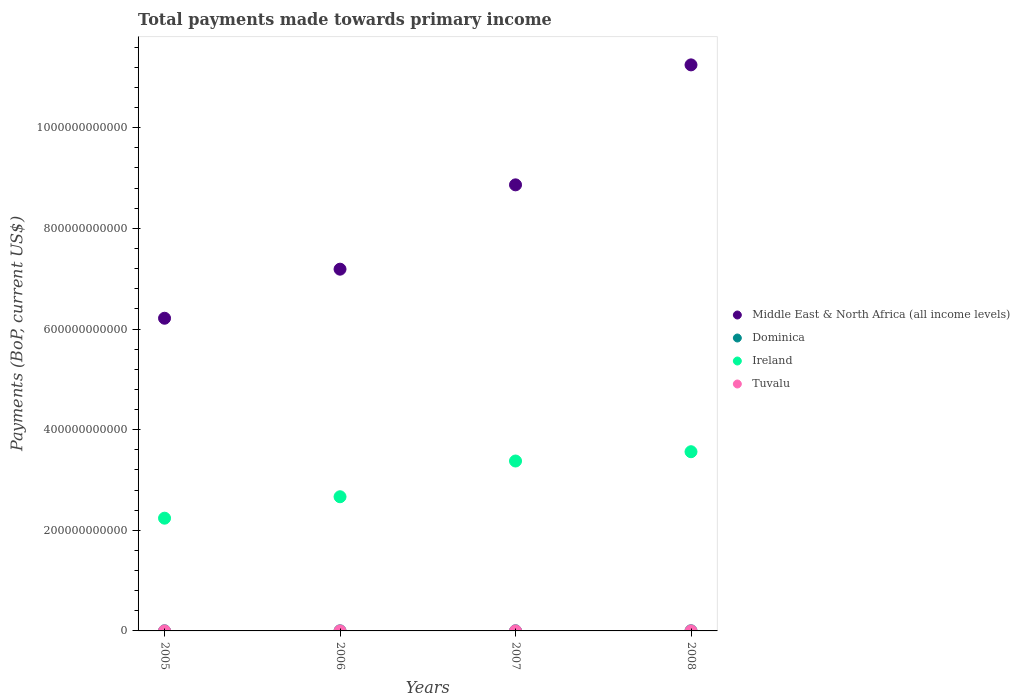How many different coloured dotlines are there?
Offer a terse response. 4. What is the total payments made towards primary income in Ireland in 2005?
Your response must be concise. 2.24e+11. Across all years, what is the maximum total payments made towards primary income in Ireland?
Offer a very short reply. 3.56e+11. Across all years, what is the minimum total payments made towards primary income in Dominica?
Your response must be concise. 2.20e+08. In which year was the total payments made towards primary income in Tuvalu minimum?
Make the answer very short. 2005. What is the total total payments made towards primary income in Middle East & North Africa (all income levels) in the graph?
Offer a terse response. 3.35e+12. What is the difference between the total payments made towards primary income in Middle East & North Africa (all income levels) in 2006 and that in 2007?
Give a very brief answer. -1.68e+11. What is the difference between the total payments made towards primary income in Tuvalu in 2006 and the total payments made towards primary income in Middle East & North Africa (all income levels) in 2008?
Make the answer very short. -1.12e+12. What is the average total payments made towards primary income in Tuvalu per year?
Provide a succinct answer. 2.89e+07. In the year 2007, what is the difference between the total payments made towards primary income in Tuvalu and total payments made towards primary income in Middle East & North Africa (all income levels)?
Offer a very short reply. -8.86e+11. In how many years, is the total payments made towards primary income in Dominica greater than 640000000000 US$?
Your response must be concise. 0. What is the ratio of the total payments made towards primary income in Tuvalu in 2006 to that in 2007?
Offer a very short reply. 0.68. Is the total payments made towards primary income in Ireland in 2006 less than that in 2008?
Provide a succinct answer. Yes. What is the difference between the highest and the second highest total payments made towards primary income in Tuvalu?
Your response must be concise. 7.85e+06. What is the difference between the highest and the lowest total payments made towards primary income in Tuvalu?
Make the answer very short. 1.94e+07. Is the sum of the total payments made towards primary income in Tuvalu in 2005 and 2007 greater than the maximum total payments made towards primary income in Dominica across all years?
Offer a terse response. No. Is it the case that in every year, the sum of the total payments made towards primary income in Dominica and total payments made towards primary income in Tuvalu  is greater than the sum of total payments made towards primary income in Ireland and total payments made towards primary income in Middle East & North Africa (all income levels)?
Provide a succinct answer. No. Is it the case that in every year, the sum of the total payments made towards primary income in Tuvalu and total payments made towards primary income in Middle East & North Africa (all income levels)  is greater than the total payments made towards primary income in Ireland?
Offer a terse response. Yes. Does the total payments made towards primary income in Ireland monotonically increase over the years?
Provide a succinct answer. Yes. How many dotlines are there?
Offer a very short reply. 4. What is the difference between two consecutive major ticks on the Y-axis?
Offer a very short reply. 2.00e+11. Does the graph contain grids?
Ensure brevity in your answer.  No. Where does the legend appear in the graph?
Offer a very short reply. Center right. How many legend labels are there?
Provide a short and direct response. 4. What is the title of the graph?
Provide a succinct answer. Total payments made towards primary income. What is the label or title of the X-axis?
Your response must be concise. Years. What is the label or title of the Y-axis?
Give a very brief answer. Payments (BoP, current US$). What is the Payments (BoP, current US$) in Middle East & North Africa (all income levels) in 2005?
Your answer should be compact. 6.21e+11. What is the Payments (BoP, current US$) of Dominica in 2005?
Make the answer very short. 2.31e+08. What is the Payments (BoP, current US$) of Ireland in 2005?
Ensure brevity in your answer.  2.24e+11. What is the Payments (BoP, current US$) of Tuvalu in 2005?
Give a very brief answer. 2.09e+07. What is the Payments (BoP, current US$) in Middle East & North Africa (all income levels) in 2006?
Provide a succinct answer. 7.19e+11. What is the Payments (BoP, current US$) in Dominica in 2006?
Your answer should be very brief. 2.20e+08. What is the Payments (BoP, current US$) in Ireland in 2006?
Give a very brief answer. 2.67e+11. What is the Payments (BoP, current US$) of Tuvalu in 2006?
Ensure brevity in your answer.  2.22e+07. What is the Payments (BoP, current US$) of Middle East & North Africa (all income levels) in 2007?
Your response must be concise. 8.86e+11. What is the Payments (BoP, current US$) of Dominica in 2007?
Give a very brief answer. 2.64e+08. What is the Payments (BoP, current US$) in Ireland in 2007?
Your answer should be compact. 3.38e+11. What is the Payments (BoP, current US$) in Tuvalu in 2007?
Offer a terse response. 3.24e+07. What is the Payments (BoP, current US$) in Middle East & North Africa (all income levels) in 2008?
Give a very brief answer. 1.12e+12. What is the Payments (BoP, current US$) in Dominica in 2008?
Give a very brief answer. 3.14e+08. What is the Payments (BoP, current US$) in Ireland in 2008?
Provide a succinct answer. 3.56e+11. What is the Payments (BoP, current US$) in Tuvalu in 2008?
Ensure brevity in your answer.  4.03e+07. Across all years, what is the maximum Payments (BoP, current US$) in Middle East & North Africa (all income levels)?
Your answer should be compact. 1.12e+12. Across all years, what is the maximum Payments (BoP, current US$) of Dominica?
Provide a short and direct response. 3.14e+08. Across all years, what is the maximum Payments (BoP, current US$) in Ireland?
Keep it short and to the point. 3.56e+11. Across all years, what is the maximum Payments (BoP, current US$) in Tuvalu?
Make the answer very short. 4.03e+07. Across all years, what is the minimum Payments (BoP, current US$) in Middle East & North Africa (all income levels)?
Your answer should be compact. 6.21e+11. Across all years, what is the minimum Payments (BoP, current US$) of Dominica?
Your answer should be compact. 2.20e+08. Across all years, what is the minimum Payments (BoP, current US$) in Ireland?
Your answer should be very brief. 2.24e+11. Across all years, what is the minimum Payments (BoP, current US$) of Tuvalu?
Your response must be concise. 2.09e+07. What is the total Payments (BoP, current US$) of Middle East & North Africa (all income levels) in the graph?
Ensure brevity in your answer.  3.35e+12. What is the total Payments (BoP, current US$) in Dominica in the graph?
Your answer should be very brief. 1.03e+09. What is the total Payments (BoP, current US$) in Ireland in the graph?
Your response must be concise. 1.18e+12. What is the total Payments (BoP, current US$) of Tuvalu in the graph?
Give a very brief answer. 1.16e+08. What is the difference between the Payments (BoP, current US$) of Middle East & North Africa (all income levels) in 2005 and that in 2006?
Your answer should be compact. -9.75e+1. What is the difference between the Payments (BoP, current US$) in Dominica in 2005 and that in 2006?
Ensure brevity in your answer.  1.10e+07. What is the difference between the Payments (BoP, current US$) in Ireland in 2005 and that in 2006?
Offer a very short reply. -4.26e+1. What is the difference between the Payments (BoP, current US$) of Tuvalu in 2005 and that in 2006?
Ensure brevity in your answer.  -1.31e+06. What is the difference between the Payments (BoP, current US$) of Middle East & North Africa (all income levels) in 2005 and that in 2007?
Provide a succinct answer. -2.65e+11. What is the difference between the Payments (BoP, current US$) of Dominica in 2005 and that in 2007?
Offer a very short reply. -3.35e+07. What is the difference between the Payments (BoP, current US$) in Ireland in 2005 and that in 2007?
Your answer should be very brief. -1.14e+11. What is the difference between the Payments (BoP, current US$) of Tuvalu in 2005 and that in 2007?
Keep it short and to the point. -1.15e+07. What is the difference between the Payments (BoP, current US$) of Middle East & North Africa (all income levels) in 2005 and that in 2008?
Offer a terse response. -5.04e+11. What is the difference between the Payments (BoP, current US$) of Dominica in 2005 and that in 2008?
Offer a very short reply. -8.30e+07. What is the difference between the Payments (BoP, current US$) in Ireland in 2005 and that in 2008?
Your response must be concise. -1.32e+11. What is the difference between the Payments (BoP, current US$) of Tuvalu in 2005 and that in 2008?
Offer a very short reply. -1.94e+07. What is the difference between the Payments (BoP, current US$) in Middle East & North Africa (all income levels) in 2006 and that in 2007?
Make the answer very short. -1.68e+11. What is the difference between the Payments (BoP, current US$) of Dominica in 2006 and that in 2007?
Give a very brief answer. -4.45e+07. What is the difference between the Payments (BoP, current US$) in Ireland in 2006 and that in 2007?
Provide a succinct answer. -7.10e+1. What is the difference between the Payments (BoP, current US$) of Tuvalu in 2006 and that in 2007?
Your response must be concise. -1.02e+07. What is the difference between the Payments (BoP, current US$) in Middle East & North Africa (all income levels) in 2006 and that in 2008?
Keep it short and to the point. -4.06e+11. What is the difference between the Payments (BoP, current US$) in Dominica in 2006 and that in 2008?
Keep it short and to the point. -9.40e+07. What is the difference between the Payments (BoP, current US$) of Ireland in 2006 and that in 2008?
Make the answer very short. -8.95e+1. What is the difference between the Payments (BoP, current US$) in Tuvalu in 2006 and that in 2008?
Make the answer very short. -1.81e+07. What is the difference between the Payments (BoP, current US$) of Middle East & North Africa (all income levels) in 2007 and that in 2008?
Provide a succinct answer. -2.38e+11. What is the difference between the Payments (BoP, current US$) of Dominica in 2007 and that in 2008?
Ensure brevity in your answer.  -4.96e+07. What is the difference between the Payments (BoP, current US$) of Ireland in 2007 and that in 2008?
Give a very brief answer. -1.85e+1. What is the difference between the Payments (BoP, current US$) in Tuvalu in 2007 and that in 2008?
Give a very brief answer. -7.85e+06. What is the difference between the Payments (BoP, current US$) in Middle East & North Africa (all income levels) in 2005 and the Payments (BoP, current US$) in Dominica in 2006?
Your answer should be compact. 6.21e+11. What is the difference between the Payments (BoP, current US$) in Middle East & North Africa (all income levels) in 2005 and the Payments (BoP, current US$) in Ireland in 2006?
Offer a very short reply. 3.55e+11. What is the difference between the Payments (BoP, current US$) in Middle East & North Africa (all income levels) in 2005 and the Payments (BoP, current US$) in Tuvalu in 2006?
Give a very brief answer. 6.21e+11. What is the difference between the Payments (BoP, current US$) in Dominica in 2005 and the Payments (BoP, current US$) in Ireland in 2006?
Your response must be concise. -2.66e+11. What is the difference between the Payments (BoP, current US$) of Dominica in 2005 and the Payments (BoP, current US$) of Tuvalu in 2006?
Offer a very short reply. 2.09e+08. What is the difference between the Payments (BoP, current US$) in Ireland in 2005 and the Payments (BoP, current US$) in Tuvalu in 2006?
Ensure brevity in your answer.  2.24e+11. What is the difference between the Payments (BoP, current US$) in Middle East & North Africa (all income levels) in 2005 and the Payments (BoP, current US$) in Dominica in 2007?
Ensure brevity in your answer.  6.21e+11. What is the difference between the Payments (BoP, current US$) of Middle East & North Africa (all income levels) in 2005 and the Payments (BoP, current US$) of Ireland in 2007?
Offer a terse response. 2.84e+11. What is the difference between the Payments (BoP, current US$) of Middle East & North Africa (all income levels) in 2005 and the Payments (BoP, current US$) of Tuvalu in 2007?
Your response must be concise. 6.21e+11. What is the difference between the Payments (BoP, current US$) in Dominica in 2005 and the Payments (BoP, current US$) in Ireland in 2007?
Provide a short and direct response. -3.37e+11. What is the difference between the Payments (BoP, current US$) of Dominica in 2005 and the Payments (BoP, current US$) of Tuvalu in 2007?
Make the answer very short. 1.99e+08. What is the difference between the Payments (BoP, current US$) of Ireland in 2005 and the Payments (BoP, current US$) of Tuvalu in 2007?
Offer a very short reply. 2.24e+11. What is the difference between the Payments (BoP, current US$) in Middle East & North Africa (all income levels) in 2005 and the Payments (BoP, current US$) in Dominica in 2008?
Your response must be concise. 6.21e+11. What is the difference between the Payments (BoP, current US$) of Middle East & North Africa (all income levels) in 2005 and the Payments (BoP, current US$) of Ireland in 2008?
Offer a very short reply. 2.65e+11. What is the difference between the Payments (BoP, current US$) of Middle East & North Africa (all income levels) in 2005 and the Payments (BoP, current US$) of Tuvalu in 2008?
Your answer should be compact. 6.21e+11. What is the difference between the Payments (BoP, current US$) of Dominica in 2005 and the Payments (BoP, current US$) of Ireland in 2008?
Your response must be concise. -3.56e+11. What is the difference between the Payments (BoP, current US$) of Dominica in 2005 and the Payments (BoP, current US$) of Tuvalu in 2008?
Provide a short and direct response. 1.91e+08. What is the difference between the Payments (BoP, current US$) in Ireland in 2005 and the Payments (BoP, current US$) in Tuvalu in 2008?
Ensure brevity in your answer.  2.24e+11. What is the difference between the Payments (BoP, current US$) in Middle East & North Africa (all income levels) in 2006 and the Payments (BoP, current US$) in Dominica in 2007?
Your response must be concise. 7.19e+11. What is the difference between the Payments (BoP, current US$) of Middle East & North Africa (all income levels) in 2006 and the Payments (BoP, current US$) of Ireland in 2007?
Provide a short and direct response. 3.81e+11. What is the difference between the Payments (BoP, current US$) in Middle East & North Africa (all income levels) in 2006 and the Payments (BoP, current US$) in Tuvalu in 2007?
Give a very brief answer. 7.19e+11. What is the difference between the Payments (BoP, current US$) of Dominica in 2006 and the Payments (BoP, current US$) of Ireland in 2007?
Your answer should be compact. -3.37e+11. What is the difference between the Payments (BoP, current US$) of Dominica in 2006 and the Payments (BoP, current US$) of Tuvalu in 2007?
Ensure brevity in your answer.  1.88e+08. What is the difference between the Payments (BoP, current US$) in Ireland in 2006 and the Payments (BoP, current US$) in Tuvalu in 2007?
Keep it short and to the point. 2.67e+11. What is the difference between the Payments (BoP, current US$) in Middle East & North Africa (all income levels) in 2006 and the Payments (BoP, current US$) in Dominica in 2008?
Your answer should be very brief. 7.19e+11. What is the difference between the Payments (BoP, current US$) in Middle East & North Africa (all income levels) in 2006 and the Payments (BoP, current US$) in Ireland in 2008?
Your answer should be compact. 3.63e+11. What is the difference between the Payments (BoP, current US$) in Middle East & North Africa (all income levels) in 2006 and the Payments (BoP, current US$) in Tuvalu in 2008?
Your answer should be very brief. 7.19e+11. What is the difference between the Payments (BoP, current US$) in Dominica in 2006 and the Payments (BoP, current US$) in Ireland in 2008?
Your response must be concise. -3.56e+11. What is the difference between the Payments (BoP, current US$) in Dominica in 2006 and the Payments (BoP, current US$) in Tuvalu in 2008?
Give a very brief answer. 1.80e+08. What is the difference between the Payments (BoP, current US$) in Ireland in 2006 and the Payments (BoP, current US$) in Tuvalu in 2008?
Your answer should be very brief. 2.67e+11. What is the difference between the Payments (BoP, current US$) of Middle East & North Africa (all income levels) in 2007 and the Payments (BoP, current US$) of Dominica in 2008?
Your answer should be very brief. 8.86e+11. What is the difference between the Payments (BoP, current US$) of Middle East & North Africa (all income levels) in 2007 and the Payments (BoP, current US$) of Ireland in 2008?
Provide a short and direct response. 5.30e+11. What is the difference between the Payments (BoP, current US$) in Middle East & North Africa (all income levels) in 2007 and the Payments (BoP, current US$) in Tuvalu in 2008?
Your answer should be compact. 8.86e+11. What is the difference between the Payments (BoP, current US$) of Dominica in 2007 and the Payments (BoP, current US$) of Ireland in 2008?
Provide a succinct answer. -3.56e+11. What is the difference between the Payments (BoP, current US$) of Dominica in 2007 and the Payments (BoP, current US$) of Tuvalu in 2008?
Make the answer very short. 2.24e+08. What is the difference between the Payments (BoP, current US$) of Ireland in 2007 and the Payments (BoP, current US$) of Tuvalu in 2008?
Provide a succinct answer. 3.38e+11. What is the average Payments (BoP, current US$) of Middle East & North Africa (all income levels) per year?
Ensure brevity in your answer.  8.38e+11. What is the average Payments (BoP, current US$) in Dominica per year?
Provide a succinct answer. 2.57e+08. What is the average Payments (BoP, current US$) of Ireland per year?
Ensure brevity in your answer.  2.96e+11. What is the average Payments (BoP, current US$) of Tuvalu per year?
Provide a succinct answer. 2.89e+07. In the year 2005, what is the difference between the Payments (BoP, current US$) in Middle East & North Africa (all income levels) and Payments (BoP, current US$) in Dominica?
Your answer should be compact. 6.21e+11. In the year 2005, what is the difference between the Payments (BoP, current US$) in Middle East & North Africa (all income levels) and Payments (BoP, current US$) in Ireland?
Make the answer very short. 3.97e+11. In the year 2005, what is the difference between the Payments (BoP, current US$) in Middle East & North Africa (all income levels) and Payments (BoP, current US$) in Tuvalu?
Give a very brief answer. 6.21e+11. In the year 2005, what is the difference between the Payments (BoP, current US$) in Dominica and Payments (BoP, current US$) in Ireland?
Your answer should be compact. -2.24e+11. In the year 2005, what is the difference between the Payments (BoP, current US$) in Dominica and Payments (BoP, current US$) in Tuvalu?
Give a very brief answer. 2.10e+08. In the year 2005, what is the difference between the Payments (BoP, current US$) in Ireland and Payments (BoP, current US$) in Tuvalu?
Your answer should be very brief. 2.24e+11. In the year 2006, what is the difference between the Payments (BoP, current US$) in Middle East & North Africa (all income levels) and Payments (BoP, current US$) in Dominica?
Ensure brevity in your answer.  7.19e+11. In the year 2006, what is the difference between the Payments (BoP, current US$) in Middle East & North Africa (all income levels) and Payments (BoP, current US$) in Ireland?
Provide a succinct answer. 4.52e+11. In the year 2006, what is the difference between the Payments (BoP, current US$) of Middle East & North Africa (all income levels) and Payments (BoP, current US$) of Tuvalu?
Your response must be concise. 7.19e+11. In the year 2006, what is the difference between the Payments (BoP, current US$) of Dominica and Payments (BoP, current US$) of Ireland?
Give a very brief answer. -2.66e+11. In the year 2006, what is the difference between the Payments (BoP, current US$) in Dominica and Payments (BoP, current US$) in Tuvalu?
Your response must be concise. 1.98e+08. In the year 2006, what is the difference between the Payments (BoP, current US$) of Ireland and Payments (BoP, current US$) of Tuvalu?
Offer a terse response. 2.67e+11. In the year 2007, what is the difference between the Payments (BoP, current US$) in Middle East & North Africa (all income levels) and Payments (BoP, current US$) in Dominica?
Offer a very short reply. 8.86e+11. In the year 2007, what is the difference between the Payments (BoP, current US$) in Middle East & North Africa (all income levels) and Payments (BoP, current US$) in Ireland?
Make the answer very short. 5.49e+11. In the year 2007, what is the difference between the Payments (BoP, current US$) of Middle East & North Africa (all income levels) and Payments (BoP, current US$) of Tuvalu?
Offer a terse response. 8.86e+11. In the year 2007, what is the difference between the Payments (BoP, current US$) in Dominica and Payments (BoP, current US$) in Ireland?
Offer a very short reply. -3.37e+11. In the year 2007, what is the difference between the Payments (BoP, current US$) of Dominica and Payments (BoP, current US$) of Tuvalu?
Make the answer very short. 2.32e+08. In the year 2007, what is the difference between the Payments (BoP, current US$) in Ireland and Payments (BoP, current US$) in Tuvalu?
Provide a succinct answer. 3.38e+11. In the year 2008, what is the difference between the Payments (BoP, current US$) of Middle East & North Africa (all income levels) and Payments (BoP, current US$) of Dominica?
Offer a terse response. 1.12e+12. In the year 2008, what is the difference between the Payments (BoP, current US$) of Middle East & North Africa (all income levels) and Payments (BoP, current US$) of Ireland?
Offer a terse response. 7.69e+11. In the year 2008, what is the difference between the Payments (BoP, current US$) in Middle East & North Africa (all income levels) and Payments (BoP, current US$) in Tuvalu?
Offer a terse response. 1.12e+12. In the year 2008, what is the difference between the Payments (BoP, current US$) in Dominica and Payments (BoP, current US$) in Ireland?
Provide a succinct answer. -3.56e+11. In the year 2008, what is the difference between the Payments (BoP, current US$) in Dominica and Payments (BoP, current US$) in Tuvalu?
Keep it short and to the point. 2.74e+08. In the year 2008, what is the difference between the Payments (BoP, current US$) of Ireland and Payments (BoP, current US$) of Tuvalu?
Provide a succinct answer. 3.56e+11. What is the ratio of the Payments (BoP, current US$) in Middle East & North Africa (all income levels) in 2005 to that in 2006?
Ensure brevity in your answer.  0.86. What is the ratio of the Payments (BoP, current US$) of Dominica in 2005 to that in 2006?
Make the answer very short. 1.05. What is the ratio of the Payments (BoP, current US$) in Ireland in 2005 to that in 2006?
Your answer should be very brief. 0.84. What is the ratio of the Payments (BoP, current US$) in Tuvalu in 2005 to that in 2006?
Provide a short and direct response. 0.94. What is the ratio of the Payments (BoP, current US$) in Middle East & North Africa (all income levels) in 2005 to that in 2007?
Your answer should be very brief. 0.7. What is the ratio of the Payments (BoP, current US$) in Dominica in 2005 to that in 2007?
Keep it short and to the point. 0.87. What is the ratio of the Payments (BoP, current US$) of Ireland in 2005 to that in 2007?
Give a very brief answer. 0.66. What is the ratio of the Payments (BoP, current US$) in Tuvalu in 2005 to that in 2007?
Give a very brief answer. 0.64. What is the ratio of the Payments (BoP, current US$) of Middle East & North Africa (all income levels) in 2005 to that in 2008?
Keep it short and to the point. 0.55. What is the ratio of the Payments (BoP, current US$) of Dominica in 2005 to that in 2008?
Your response must be concise. 0.74. What is the ratio of the Payments (BoP, current US$) of Ireland in 2005 to that in 2008?
Keep it short and to the point. 0.63. What is the ratio of the Payments (BoP, current US$) in Tuvalu in 2005 to that in 2008?
Provide a succinct answer. 0.52. What is the ratio of the Payments (BoP, current US$) in Middle East & North Africa (all income levels) in 2006 to that in 2007?
Your answer should be very brief. 0.81. What is the ratio of the Payments (BoP, current US$) in Dominica in 2006 to that in 2007?
Ensure brevity in your answer.  0.83. What is the ratio of the Payments (BoP, current US$) of Ireland in 2006 to that in 2007?
Keep it short and to the point. 0.79. What is the ratio of the Payments (BoP, current US$) of Tuvalu in 2006 to that in 2007?
Offer a terse response. 0.68. What is the ratio of the Payments (BoP, current US$) of Middle East & North Africa (all income levels) in 2006 to that in 2008?
Provide a short and direct response. 0.64. What is the ratio of the Payments (BoP, current US$) of Dominica in 2006 to that in 2008?
Offer a very short reply. 0.7. What is the ratio of the Payments (BoP, current US$) of Ireland in 2006 to that in 2008?
Offer a very short reply. 0.75. What is the ratio of the Payments (BoP, current US$) of Tuvalu in 2006 to that in 2008?
Keep it short and to the point. 0.55. What is the ratio of the Payments (BoP, current US$) in Middle East & North Africa (all income levels) in 2007 to that in 2008?
Your response must be concise. 0.79. What is the ratio of the Payments (BoP, current US$) in Dominica in 2007 to that in 2008?
Your answer should be very brief. 0.84. What is the ratio of the Payments (BoP, current US$) in Ireland in 2007 to that in 2008?
Provide a succinct answer. 0.95. What is the ratio of the Payments (BoP, current US$) in Tuvalu in 2007 to that in 2008?
Your answer should be very brief. 0.81. What is the difference between the highest and the second highest Payments (BoP, current US$) in Middle East & North Africa (all income levels)?
Your answer should be compact. 2.38e+11. What is the difference between the highest and the second highest Payments (BoP, current US$) in Dominica?
Give a very brief answer. 4.96e+07. What is the difference between the highest and the second highest Payments (BoP, current US$) in Ireland?
Your response must be concise. 1.85e+1. What is the difference between the highest and the second highest Payments (BoP, current US$) in Tuvalu?
Provide a short and direct response. 7.85e+06. What is the difference between the highest and the lowest Payments (BoP, current US$) of Middle East & North Africa (all income levels)?
Provide a succinct answer. 5.04e+11. What is the difference between the highest and the lowest Payments (BoP, current US$) of Dominica?
Give a very brief answer. 9.40e+07. What is the difference between the highest and the lowest Payments (BoP, current US$) in Ireland?
Keep it short and to the point. 1.32e+11. What is the difference between the highest and the lowest Payments (BoP, current US$) in Tuvalu?
Your answer should be very brief. 1.94e+07. 